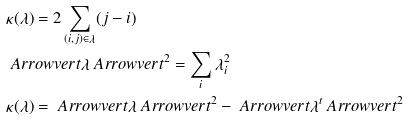Convert formula to latex. <formula><loc_0><loc_0><loc_500><loc_500>& \kappa ( \lambda ) = 2 \sum _ { ( i , j ) \in \lambda } ( j - i ) \\ & \ A r r o w v e r t \lambda \ A r r o w v e r t ^ { 2 } = \sum _ { i } \lambda _ { i } ^ { 2 } \\ & \kappa ( \lambda ) = \ A r r o w v e r t \lambda \ A r r o w v e r t ^ { 2 } - \ A r r o w v e r t \lambda ^ { t } \ A r r o w v e r t ^ { 2 }</formula> 